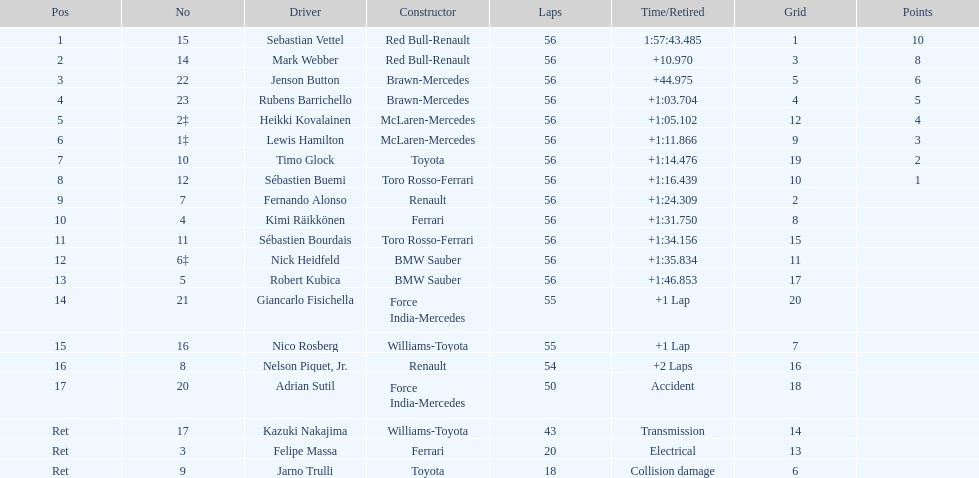Who was the shared constructor of heikki kovalainen and lewis hamilton? McLaren-Mercedes. 